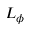Convert formula to latex. <formula><loc_0><loc_0><loc_500><loc_500>L _ { \phi }</formula> 